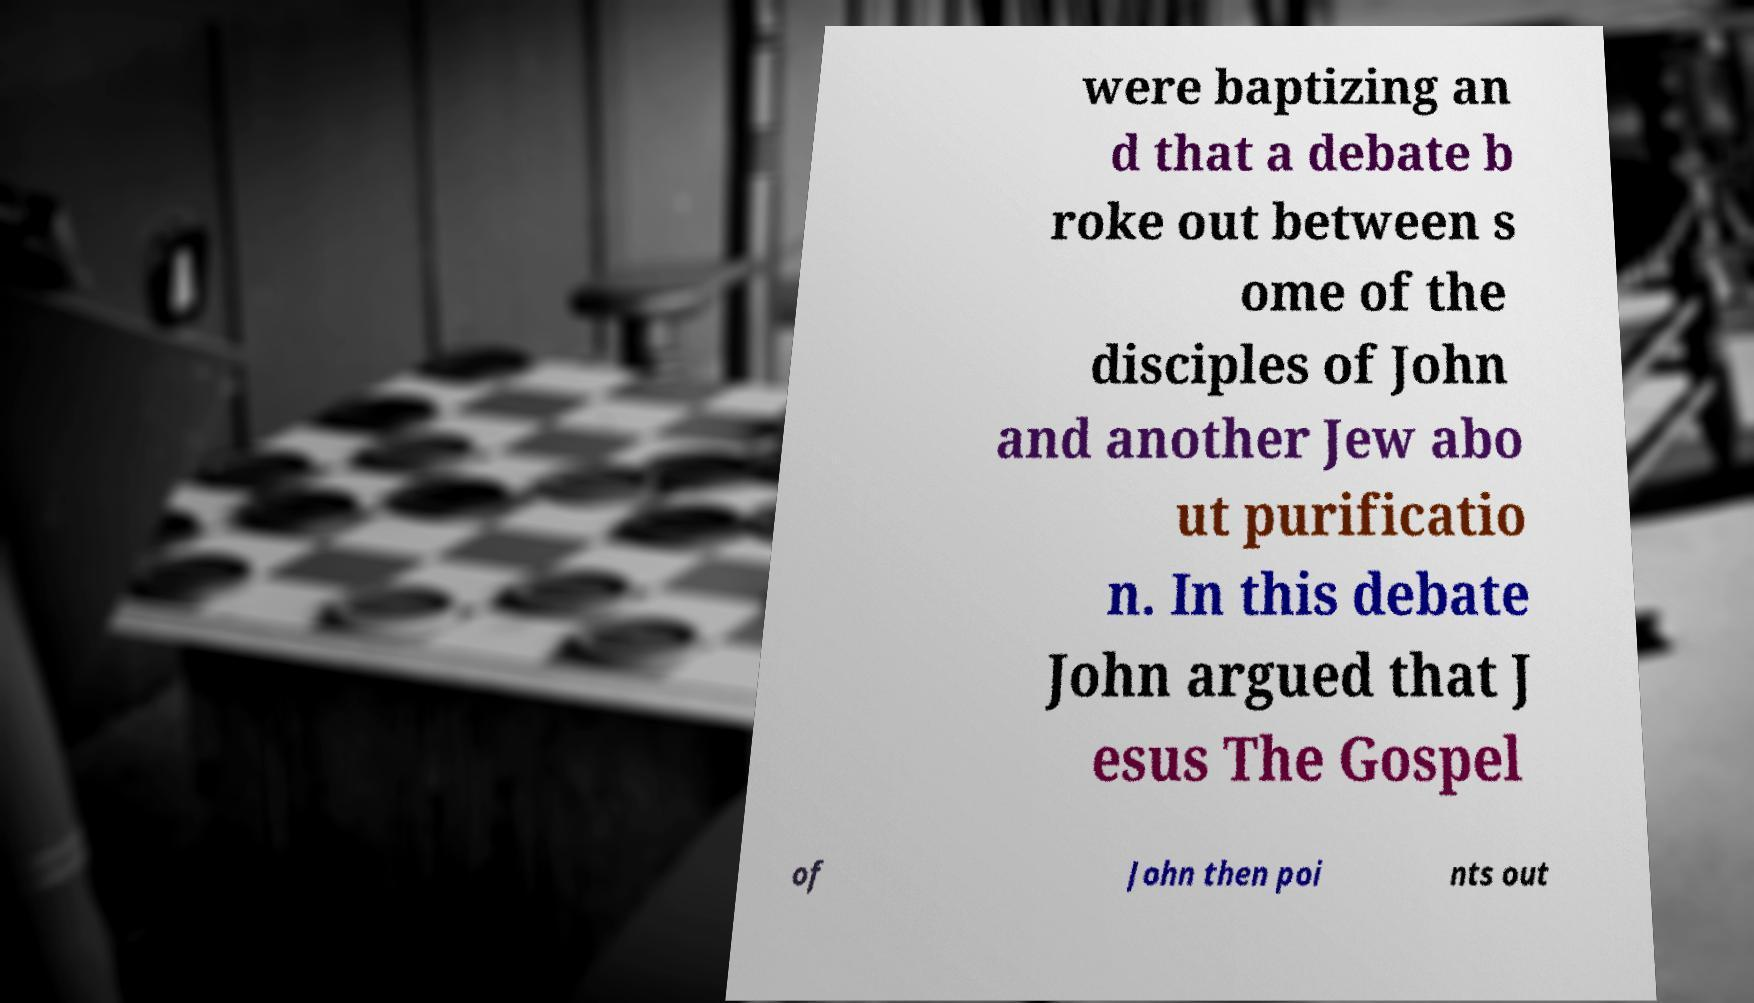For documentation purposes, I need the text within this image transcribed. Could you provide that? were baptizing an d that a debate b roke out between s ome of the disciples of John and another Jew abo ut purificatio n. In this debate John argued that J esus The Gospel of John then poi nts out 